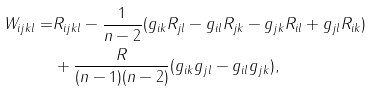Convert formula to latex. <formula><loc_0><loc_0><loc_500><loc_500>W _ { i j k l } = & R _ { i j k l } - \frac { 1 } { n - 2 } ( g _ { i k } R _ { j l } - g _ { i l } R _ { j k } - g _ { j k } R _ { i l } + g _ { j l } R _ { i k } ) \\ & + \frac { R } { ( n - 1 ) ( n - 2 ) } ( g _ { i k } g _ { j l } - g _ { i l } g _ { j k } ) , \\</formula> 